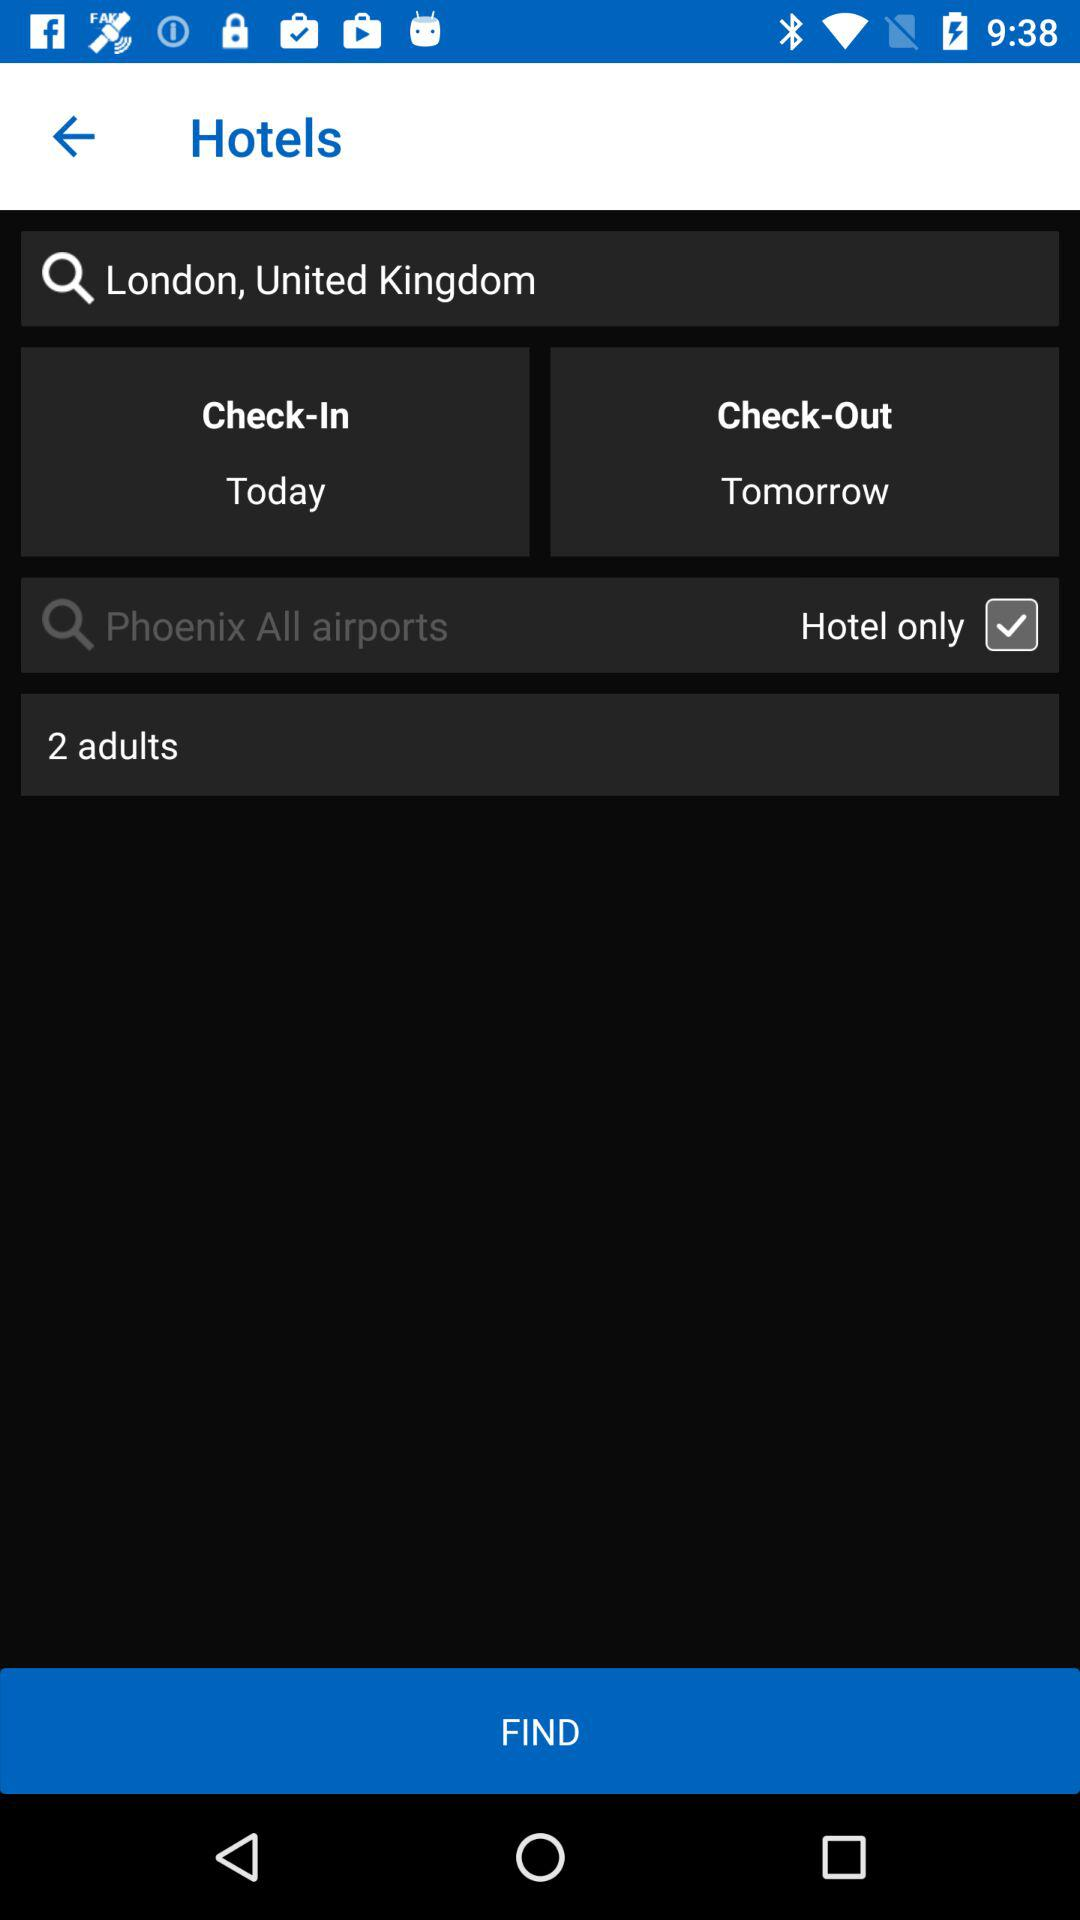When to check-in at the hotel? Check-in at the hotel today. 